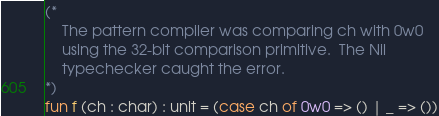<code> <loc_0><loc_0><loc_500><loc_500><_SML_>(*
	The pattern compiler was comparing ch with 0w0
	using the 32-bit comparison primitive.  The Nil
	typechecker caught the error.
*)
fun f (ch : char) : unit = (case ch of 0w0 => () | _ => ())
</code> 